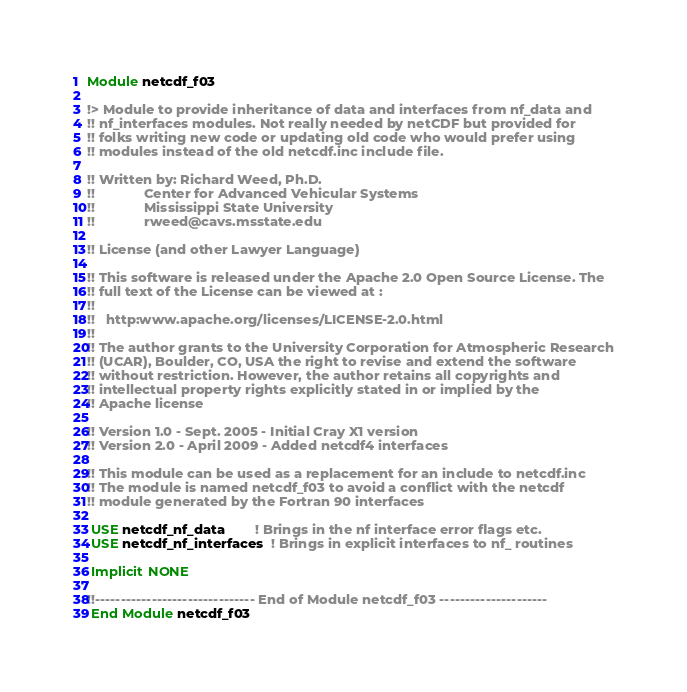<code> <loc_0><loc_0><loc_500><loc_500><_FORTRAN_>Module netcdf_f03

!> Module to provide inheritance of data and interfaces from nf_data and
!! nf_interfaces modules. Not really needed by netCDF but provided for
!! folks writing new code or updating old code who would prefer using
!! modules instead of the old netcdf.inc include file.

!! Written by: Richard Weed, Ph.D.
!!             Center for Advanced Vehicular Systems
!!             Mississippi State University
!!             rweed@cavs.msstate.edu

!! License (and other Lawyer Language)

!! This software is released under the Apache 2.0 Open Source License. The
!! full text of the License can be viewed at :
!!
!!   http:www.apache.org/licenses/LICENSE-2.0.html
!!
!! The author grants to the University Corporation for Atmospheric Research
!! (UCAR), Boulder, CO, USA the right to revise and extend the software
!! without restriction. However, the author retains all copyrights and
!! intellectual property rights explicitly stated in or implied by the
!! Apache license

!! Version 1.0 - Sept. 2005 - Initial Cray X1 version
!! Version 2.0 - April 2009 - Added netcdf4 interfaces

!! This module can be used as a replacement for an include to netcdf.inc
!! The module is named netcdf_f03 to avoid a conflict with the netcdf
!! module generated by the Fortran 90 interfaces

 USE netcdf_nf_data        ! Brings in the nf interface error flags etc.
 USE netcdf_nf_interfaces  ! Brings in explicit interfaces to nf_ routines

 Implicit NONE

!!------------------------------- End of Module netcdf_f03 ---------------------
 End Module netcdf_f03
</code> 